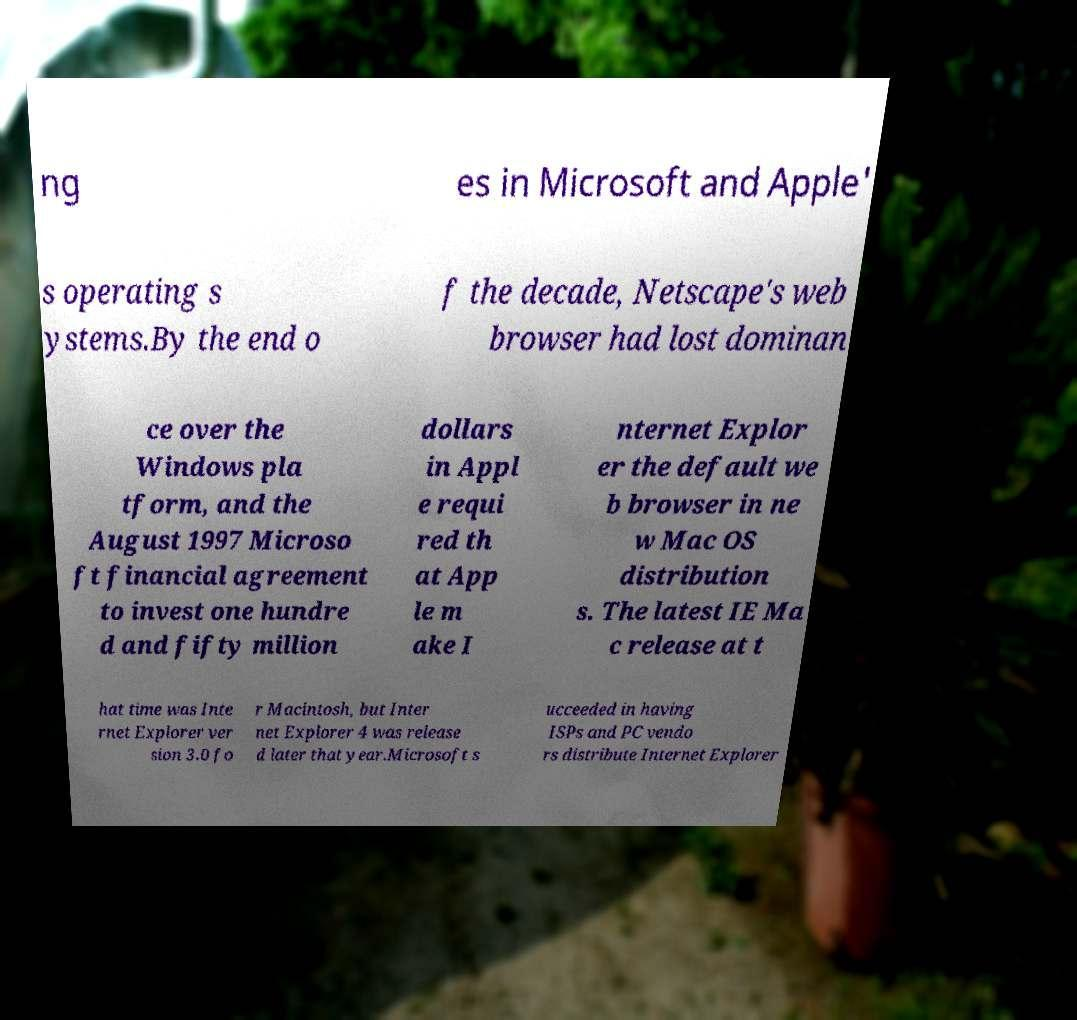I need the written content from this picture converted into text. Can you do that? ng es in Microsoft and Apple' s operating s ystems.By the end o f the decade, Netscape's web browser had lost dominan ce over the Windows pla tform, and the August 1997 Microso ft financial agreement to invest one hundre d and fifty million dollars in Appl e requi red th at App le m ake I nternet Explor er the default we b browser in ne w Mac OS distribution s. The latest IE Ma c release at t hat time was Inte rnet Explorer ver sion 3.0 fo r Macintosh, but Inter net Explorer 4 was release d later that year.Microsoft s ucceeded in having ISPs and PC vendo rs distribute Internet Explorer 